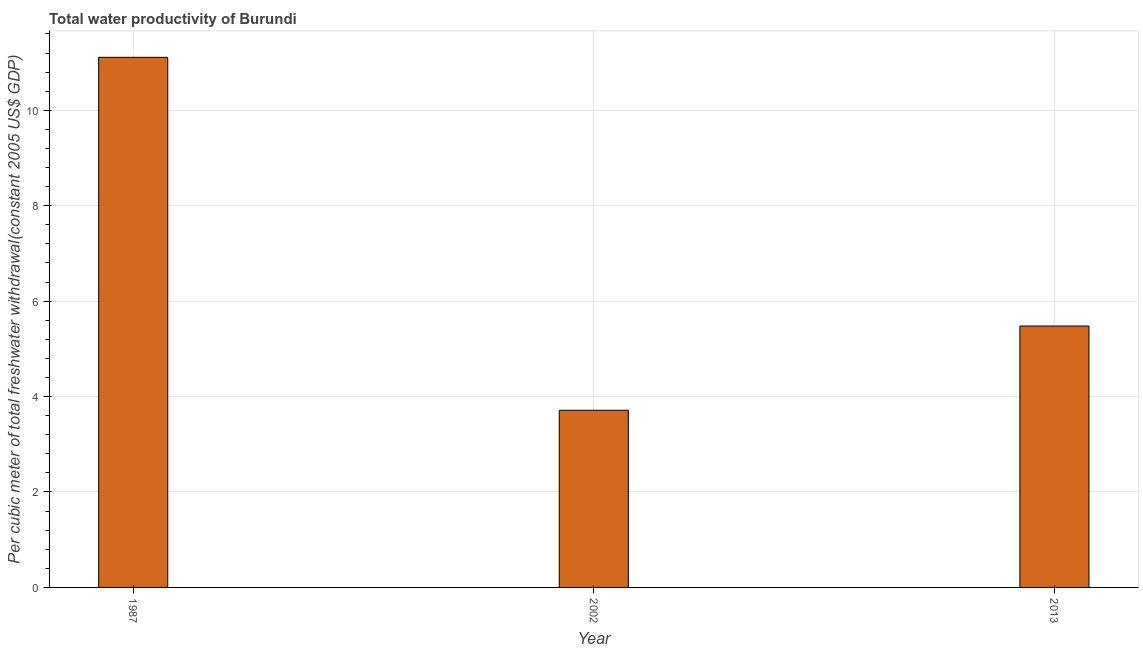Does the graph contain any zero values?
Your answer should be compact. No. Does the graph contain grids?
Give a very brief answer. Yes. What is the title of the graph?
Keep it short and to the point. Total water productivity of Burundi. What is the label or title of the X-axis?
Ensure brevity in your answer.  Year. What is the label or title of the Y-axis?
Provide a succinct answer. Per cubic meter of total freshwater withdrawal(constant 2005 US$ GDP). What is the total water productivity in 2013?
Your answer should be very brief. 5.48. Across all years, what is the maximum total water productivity?
Offer a very short reply. 11.11. Across all years, what is the minimum total water productivity?
Offer a terse response. 3.71. What is the sum of the total water productivity?
Ensure brevity in your answer.  20.3. What is the difference between the total water productivity in 1987 and 2013?
Your answer should be very brief. 5.63. What is the average total water productivity per year?
Your answer should be very brief. 6.77. What is the median total water productivity?
Keep it short and to the point. 5.48. What is the ratio of the total water productivity in 1987 to that in 2002?
Ensure brevity in your answer.  2.99. Is the total water productivity in 2002 less than that in 2013?
Keep it short and to the point. Yes. Is the difference between the total water productivity in 2002 and 2013 greater than the difference between any two years?
Offer a terse response. No. What is the difference between the highest and the second highest total water productivity?
Your answer should be compact. 5.63. Is the sum of the total water productivity in 1987 and 2013 greater than the maximum total water productivity across all years?
Your response must be concise. Yes. How many years are there in the graph?
Ensure brevity in your answer.  3. What is the difference between two consecutive major ticks on the Y-axis?
Provide a short and direct response. 2. What is the Per cubic meter of total freshwater withdrawal(constant 2005 US$ GDP) of 1987?
Offer a very short reply. 11.11. What is the Per cubic meter of total freshwater withdrawal(constant 2005 US$ GDP) in 2002?
Keep it short and to the point. 3.71. What is the Per cubic meter of total freshwater withdrawal(constant 2005 US$ GDP) of 2013?
Ensure brevity in your answer.  5.48. What is the difference between the Per cubic meter of total freshwater withdrawal(constant 2005 US$ GDP) in 1987 and 2002?
Your response must be concise. 7.4. What is the difference between the Per cubic meter of total freshwater withdrawal(constant 2005 US$ GDP) in 1987 and 2013?
Your answer should be very brief. 5.63. What is the difference between the Per cubic meter of total freshwater withdrawal(constant 2005 US$ GDP) in 2002 and 2013?
Offer a terse response. -1.77. What is the ratio of the Per cubic meter of total freshwater withdrawal(constant 2005 US$ GDP) in 1987 to that in 2002?
Provide a succinct answer. 2.99. What is the ratio of the Per cubic meter of total freshwater withdrawal(constant 2005 US$ GDP) in 1987 to that in 2013?
Ensure brevity in your answer.  2.03. What is the ratio of the Per cubic meter of total freshwater withdrawal(constant 2005 US$ GDP) in 2002 to that in 2013?
Keep it short and to the point. 0.68. 